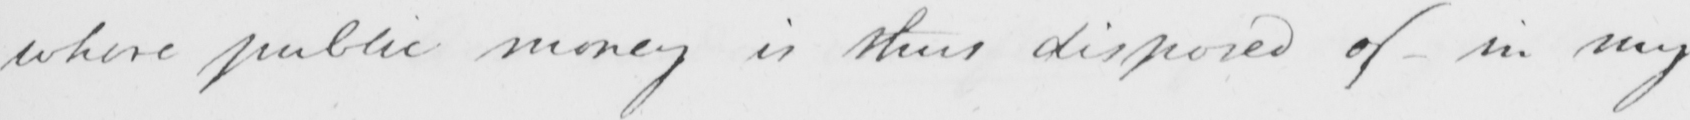What text is written in this handwritten line? where public money is thus disposed of - in my 